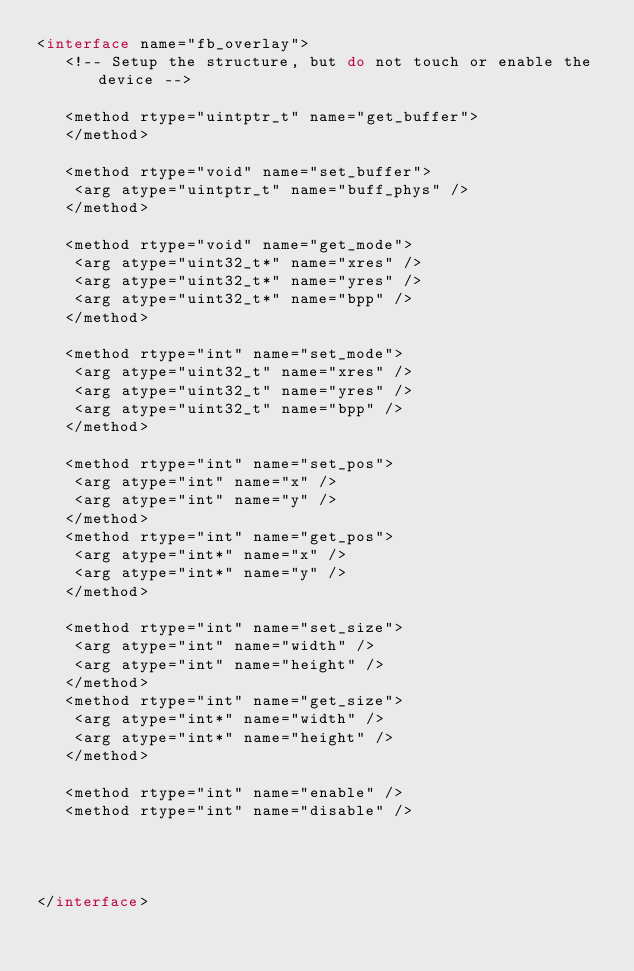<code> <loc_0><loc_0><loc_500><loc_500><_D_><interface name="fb_overlay">
   <!-- Setup the structure, but do not touch or enable the device -->

   <method rtype="uintptr_t" name="get_buffer">
   </method>

   <method rtype="void" name="set_buffer">
    <arg atype="uintptr_t" name="buff_phys" />
   </method>

   <method rtype="void" name="get_mode">
    <arg atype="uint32_t*" name="xres" />
    <arg atype="uint32_t*" name="yres" />
    <arg atype="uint32_t*" name="bpp" />
   </method>

   <method rtype="int" name="set_mode">
    <arg atype="uint32_t" name="xres" />
    <arg atype="uint32_t" name="yres" />
    <arg atype="uint32_t" name="bpp" />
   </method>

   <method rtype="int" name="set_pos">
    <arg atype="int" name="x" />
    <arg atype="int" name="y" />
   </method>
   <method rtype="int" name="get_pos">
    <arg atype="int*" name="x" />
    <arg atype="int*" name="y" />
   </method>

   <method rtype="int" name="set_size">
    <arg atype="int" name="width" />
    <arg atype="int" name="height" />
   </method>
   <method rtype="int" name="get_size">
    <arg atype="int*" name="width" />
    <arg atype="int*" name="height" />
   </method>

   <method rtype="int" name="enable" />
   <method rtype="int" name="disable" />




</interface>

</code> 